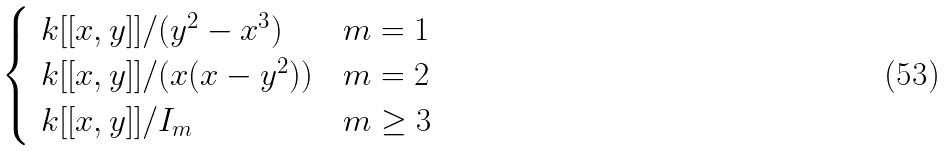<formula> <loc_0><loc_0><loc_500><loc_500>\begin{cases} \ k [ [ x , y ] ] / ( y ^ { 2 } - x ^ { 3 } ) & m = 1 \\ \ k [ [ x , y ] ] / ( x ( x - y ^ { 2 } ) ) & m = 2 \\ \ k [ [ x , y ] ] / I _ { m } & m \geq 3 \end{cases}</formula> 